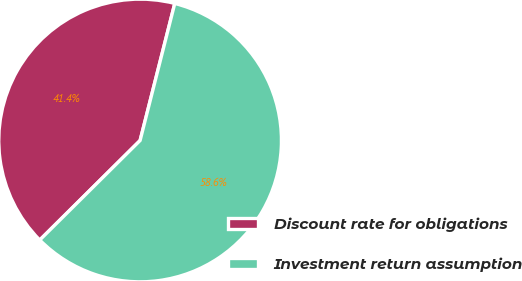<chart> <loc_0><loc_0><loc_500><loc_500><pie_chart><fcel>Discount rate for obligations<fcel>Investment return assumption<nl><fcel>41.38%<fcel>58.62%<nl></chart> 